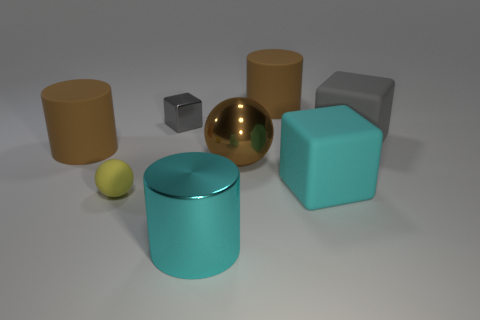Add 1 big cyan rubber blocks. How many objects exist? 9 Subtract all big rubber cylinders. How many cylinders are left? 1 Subtract all gray blocks. How many blocks are left? 1 Subtract all balls. How many objects are left? 6 Subtract 2 cubes. How many cubes are left? 1 Add 8 large yellow rubber things. How many large yellow rubber things exist? 8 Subtract 0 blue balls. How many objects are left? 8 Subtract all blue balls. Subtract all green cylinders. How many balls are left? 2 Subtract all gray blocks. How many yellow cylinders are left? 0 Subtract all shiny objects. Subtract all small gray metallic blocks. How many objects are left? 4 